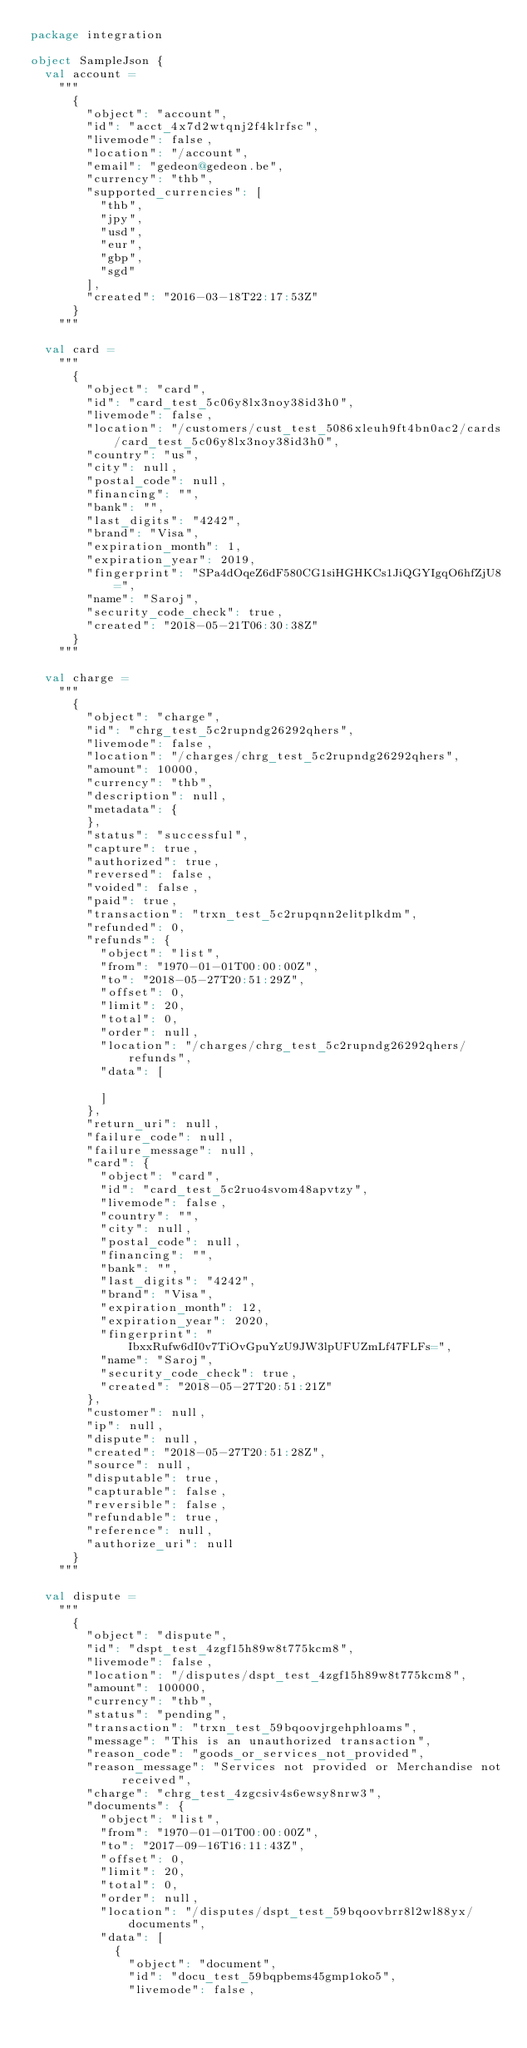<code> <loc_0><loc_0><loc_500><loc_500><_Scala_>package integration

object SampleJson {
  val account =
    """
      {
        "object": "account",
        "id": "acct_4x7d2wtqnj2f4klrfsc",
        "livemode": false,
        "location": "/account",
        "email": "gedeon@gedeon.be",
        "currency": "thb",
        "supported_currencies": [
          "thb",
          "jpy",
          "usd",
          "eur",
          "gbp",
          "sgd"
        ],
        "created": "2016-03-18T22:17:53Z"
      }
    """

  val card =
    """
      {
        "object": "card",
        "id": "card_test_5c06y8lx3noy38id3h0",
        "livemode": false,
        "location": "/customers/cust_test_5086xleuh9ft4bn0ac2/cards/card_test_5c06y8lx3noy38id3h0",
        "country": "us",
        "city": null,
        "postal_code": null,
        "financing": "",
        "bank": "",
        "last_digits": "4242",
        "brand": "Visa",
        "expiration_month": 1,
        "expiration_year": 2019,
        "fingerprint": "SPa4dOqeZ6dF580CG1siHGHKCs1JiQGYIgqO6hfZjU8=",
        "name": "Saroj",
        "security_code_check": true,
        "created": "2018-05-21T06:30:38Z"
      }
    """

  val charge =
    """
      {
        "object": "charge",
        "id": "chrg_test_5c2rupndg26292qhers",
        "livemode": false,
        "location": "/charges/chrg_test_5c2rupndg26292qhers",
        "amount": 10000,
        "currency": "thb",
        "description": null,
        "metadata": {
        },
        "status": "successful",
        "capture": true,
        "authorized": true,
        "reversed": false,
        "voided": false,
        "paid": true,
        "transaction": "trxn_test_5c2rupqnn2elitplkdm",
        "refunded": 0,
        "refunds": {
          "object": "list",
          "from": "1970-01-01T00:00:00Z",
          "to": "2018-05-27T20:51:29Z",
          "offset": 0,
          "limit": 20,
          "total": 0,
          "order": null,
          "location": "/charges/chrg_test_5c2rupndg26292qhers/refunds",
          "data": [
      
          ]
        },
        "return_uri": null,
        "failure_code": null,
        "failure_message": null,
        "card": {
          "object": "card",
          "id": "card_test_5c2ruo4svom48apvtzy",
          "livemode": false,
          "country": "",
          "city": null,
          "postal_code": null,
          "financing": "",
          "bank": "",
          "last_digits": "4242",
          "brand": "Visa",
          "expiration_month": 12,
          "expiration_year": 2020,
          "fingerprint": "IbxxRufw6dI0v7TiOvGpuYzU9JW3lpUFUZmLf47FLFs=",
          "name": "Saroj",
          "security_code_check": true,
          "created": "2018-05-27T20:51:21Z"
        },
        "customer": null,
        "ip": null,
        "dispute": null,
        "created": "2018-05-27T20:51:28Z",
        "source": null,
        "disputable": true,
        "capturable": false,
        "reversible": false,
        "refundable": true,
        "reference": null,
        "authorize_uri": null
      }
    """

  val dispute =
    """
      {
        "object": "dispute",
        "id": "dspt_test_4zgf15h89w8t775kcm8",
        "livemode": false,
        "location": "/disputes/dspt_test_4zgf15h89w8t775kcm8",
        "amount": 100000,
        "currency": "thb",
        "status": "pending",
        "transaction": "trxn_test_59bqoovjrgehphloams",
        "message": "This is an unauthorized transaction",
        "reason_code": "goods_or_services_not_provided",
        "reason_message": "Services not provided or Merchandise not received",
        "charge": "chrg_test_4zgcsiv4s6ewsy8nrw3",
        "documents": {
          "object": "list",
          "from": "1970-01-01T00:00:00Z",
          "to": "2017-09-16T16:11:43Z",
          "offset": 0,
          "limit": 20,
          "total": 0,
          "order": null,
          "location": "/disputes/dspt_test_59bqoovbrr8l2wl88yx/documents",
          "data": [
            {
              "object": "document",
              "id": "docu_test_59bqpbems45gmp1oko5",
              "livemode": false,</code> 